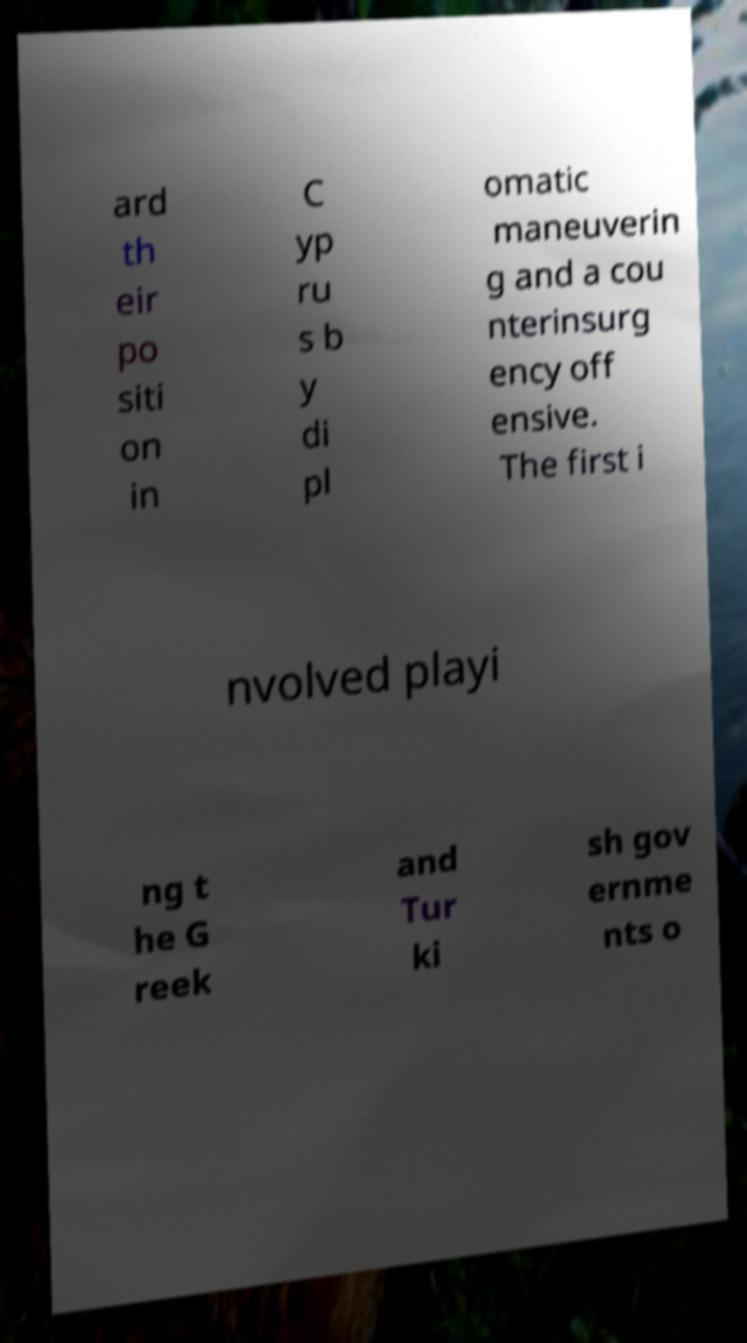For documentation purposes, I need the text within this image transcribed. Could you provide that? ard th eir po siti on in C yp ru s b y di pl omatic maneuverin g and a cou nterinsurg ency off ensive. The first i nvolved playi ng t he G reek and Tur ki sh gov ernme nts o 